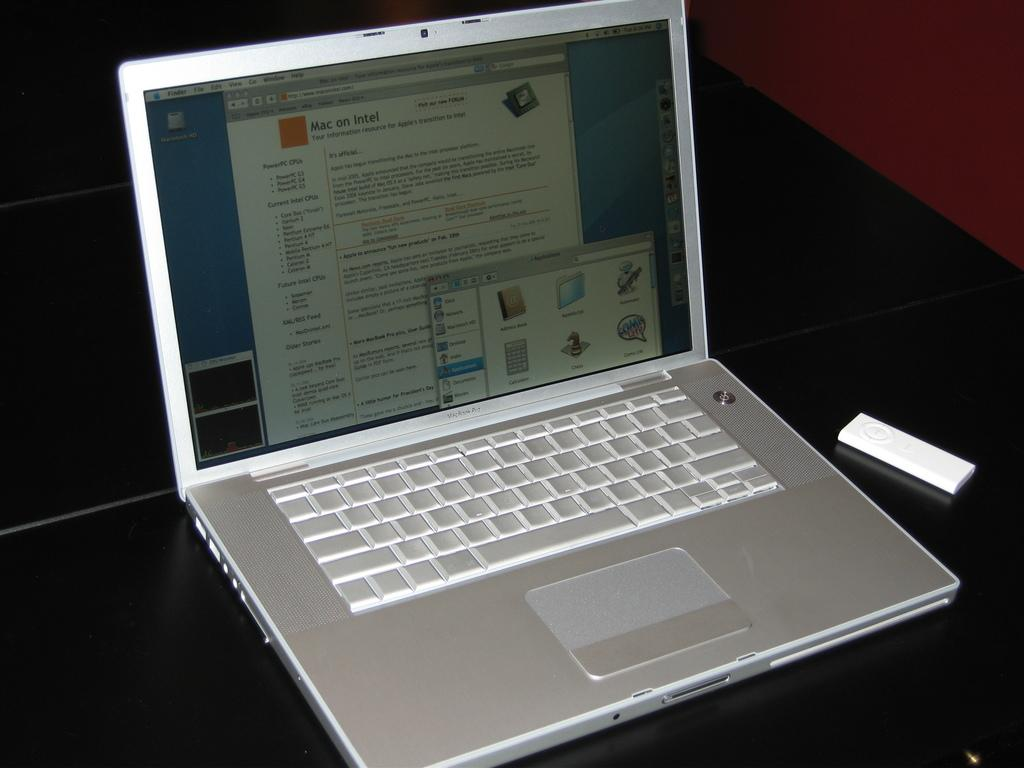<image>
Describe the image concisely. Silver and white MacBook Pro laptop that says Mac on Intel on the screen. 